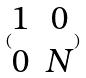<formula> <loc_0><loc_0><loc_500><loc_500>( \begin{matrix} 1 & 0 \\ 0 & N \end{matrix} )</formula> 